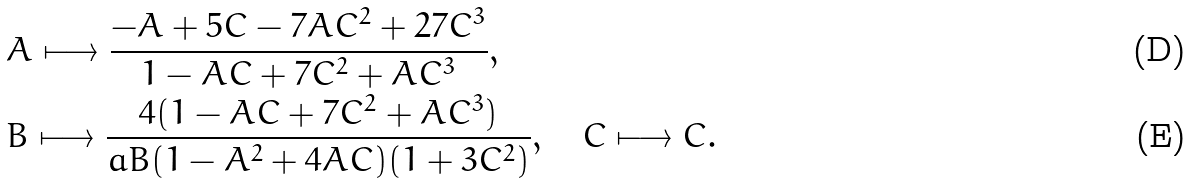<formula> <loc_0><loc_0><loc_500><loc_500>& A \longmapsto \frac { - A + 5 C - 7 A C ^ { 2 } + 2 7 C ^ { 3 } } { 1 - A C + 7 C ^ { 2 } + A C ^ { 3 } } , \\ & B \longmapsto \frac { 4 ( 1 - A C + 7 C ^ { 2 } + A C ^ { 3 } ) } { a B ( 1 - A ^ { 2 } + 4 A C ) ( 1 + 3 C ^ { 2 } ) } , \quad C \longmapsto C .</formula> 